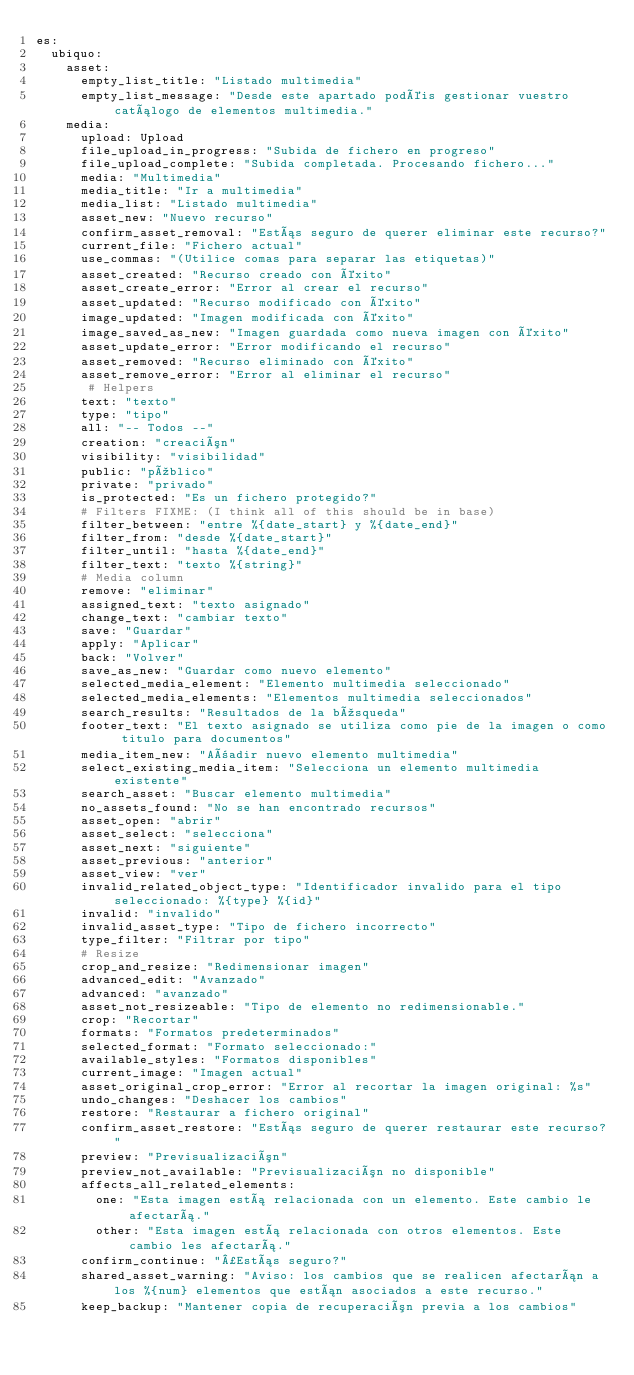<code> <loc_0><loc_0><loc_500><loc_500><_YAML_>es:
  ubiquo:
    asset:
      empty_list_title: "Listado multimedia"
      empty_list_message: "Desde este apartado podéis gestionar vuestro catálogo de elementos multimedia."
    media:
      upload: Upload
      file_upload_in_progress: "Subida de fichero en progreso"
      file_upload_complete: "Subida completada. Procesando fichero..."
      media: "Multimedia"
      media_title: "Ir a multimedia"
      media_list: "Listado multimedia"
      asset_new: "Nuevo recurso"
      confirm_asset_removal: "Estás seguro de querer eliminar este recurso?"
      current_file: "Fichero actual"
      use_commas: "(Utilice comas para separar las etiquetas)"
      asset_created: "Recurso creado con éxito"
      asset_create_error: "Error al crear el recurso"
      asset_updated: "Recurso modificado con éxito"
      image_updated: "Imagen modificada con éxito"
      image_saved_as_new: "Imagen guardada como nueva imagen con éxito"
      asset_update_error: "Error modificando el recurso"
      asset_removed: "Recurso eliminado con éxito"
      asset_remove_error: "Error al eliminar el recurso"
       # Helpers
      text: "texto"
      type: "tipo"
      all: "-- Todos --"
      creation: "creación"
      visibility: "visibilidad"
      public: "público"
      private: "privado"
      is_protected: "Es un fichero protegido?"
      # Filters FIXME: (I think all of this should be in base)
      filter_between: "entre %{date_start} y %{date_end}"
      filter_from: "desde %{date_start}"
      filter_until: "hasta %{date_end}"
      filter_text: "texto %{string}"
      # Media column
      remove: "eliminar"
      assigned_text: "texto asignado"
      change_text: "cambiar texto"
      save: "Guardar"
      apply: "Aplicar"
      back: "Volver"
      save_as_new: "Guardar como nuevo elemento"
      selected_media_element: "Elemento multimedia seleccionado"
      selected_media_elements: "Elementos multimedia seleccionados"
      search_results: "Resultados de la búsqueda"
      footer_text: "El texto asignado se utiliza como pie de la imagen o como titulo para documentos"
      media_item_new: "Añadir nuevo elemento multimedia"
      select_existing_media_item: "Selecciona un elemento multimedia existente"
      search_asset: "Buscar elemento multimedia"
      no_assets_found: "No se han encontrado recursos"
      asset_open: "abrir"
      asset_select: "selecciona"
      asset_next: "siguiente"
      asset_previous: "anterior"
      asset_view: "ver"
      invalid_related_object_type: "Identificador invalido para el tipo seleccionado: %{type} %{id}"
      invalid: "invalido"
      invalid_asset_type: "Tipo de fichero incorrecto"
      type_filter: "Filtrar por tipo"
      # Resize
      crop_and_resize: "Redimensionar imagen"
      advanced_edit: "Avanzado"
      advanced: "avanzado"
      asset_not_resizeable: "Tipo de elemento no redimensionable."
      crop: "Recortar"
      formats: "Formatos predeterminados"
      selected_format: "Formato seleccionado:"
      available_styles: "Formatos disponibles"
      current_image: "Imagen actual"
      asset_original_crop_error: "Error al recortar la imagen original: %s"
      undo_changes: "Deshacer los cambios"
      restore: "Restaurar a fichero original"
      confirm_asset_restore: "Estás seguro de querer restaurar este recurso?"
      preview: "Previsualización"
      preview_not_available: "Previsualización no disponible"
      affects_all_related_elements:
        one: "Esta imagen está relacionada con un elemento. Este cambio le afectará."
        other: "Esta imagen está relacionada con otros elementos. Este cambio les afectará."
      confirm_continue: "¿Estás seguro?"
      shared_asset_warning: "Aviso: los cambios que se realicen afectarán a los %{num} elementos que están asociados a este recurso."
      keep_backup: "Mantener copia de recuperación previa a los cambios"</code> 